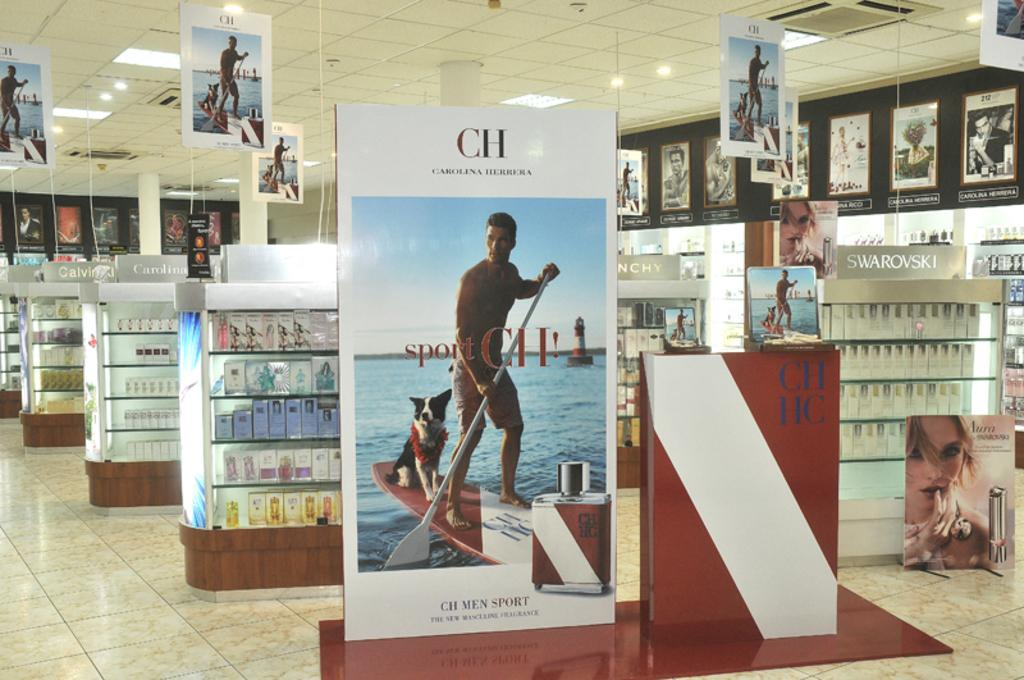<image>
Describe the image concisely. A fragrance department of a store with many posters for CH Men Sport. 